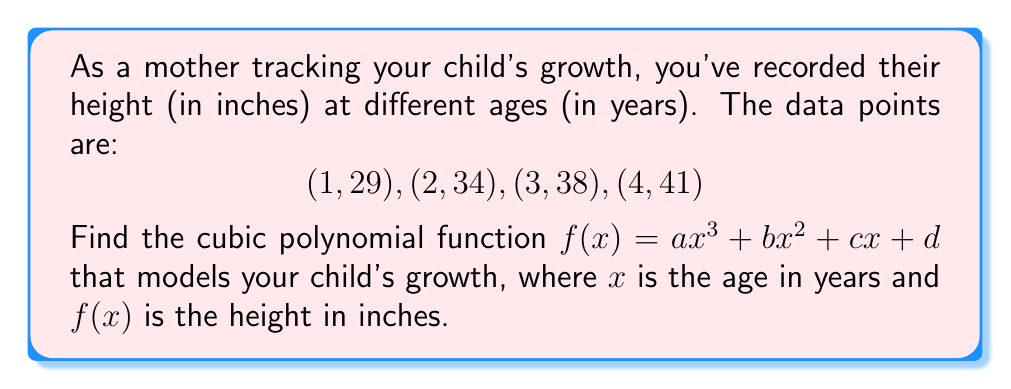Help me with this question. To find the cubic polynomial function, we'll use the given data points to create a system of equations:

1) Set up the equations:
   $a(1)^3 + b(1)^2 + c(1) + d = 29$
   $a(2)^3 + b(2)^2 + c(2) + d = 34$
   $a(3)^3 + b(3)^2 + c(3) + d = 38$
   $a(4)^3 + b(4)^2 + c(4) + d = 41$

2) Simplify:
   $a + b + c + d = 29$
   $8a + 4b + 2c + d = 34$
   $27a + 9b + 3c + d = 38$
   $64a + 16b + 4c + d = 41$

3) Solve this system of equations using elimination or matrix methods. After calculations, we get:
   $a = -0.5$
   $b = 3$
   $c = -1.5$
   $d = 28$

4) Therefore, the cubic polynomial function is:
   $f(x) = -0.5x^3 + 3x^2 - 1.5x + 28$

This function models the child's growth rate, where $x$ is the age in years and $f(x)$ is the height in inches.
Answer: $f(x) = -0.5x^3 + 3x^2 - 1.5x + 28$ 